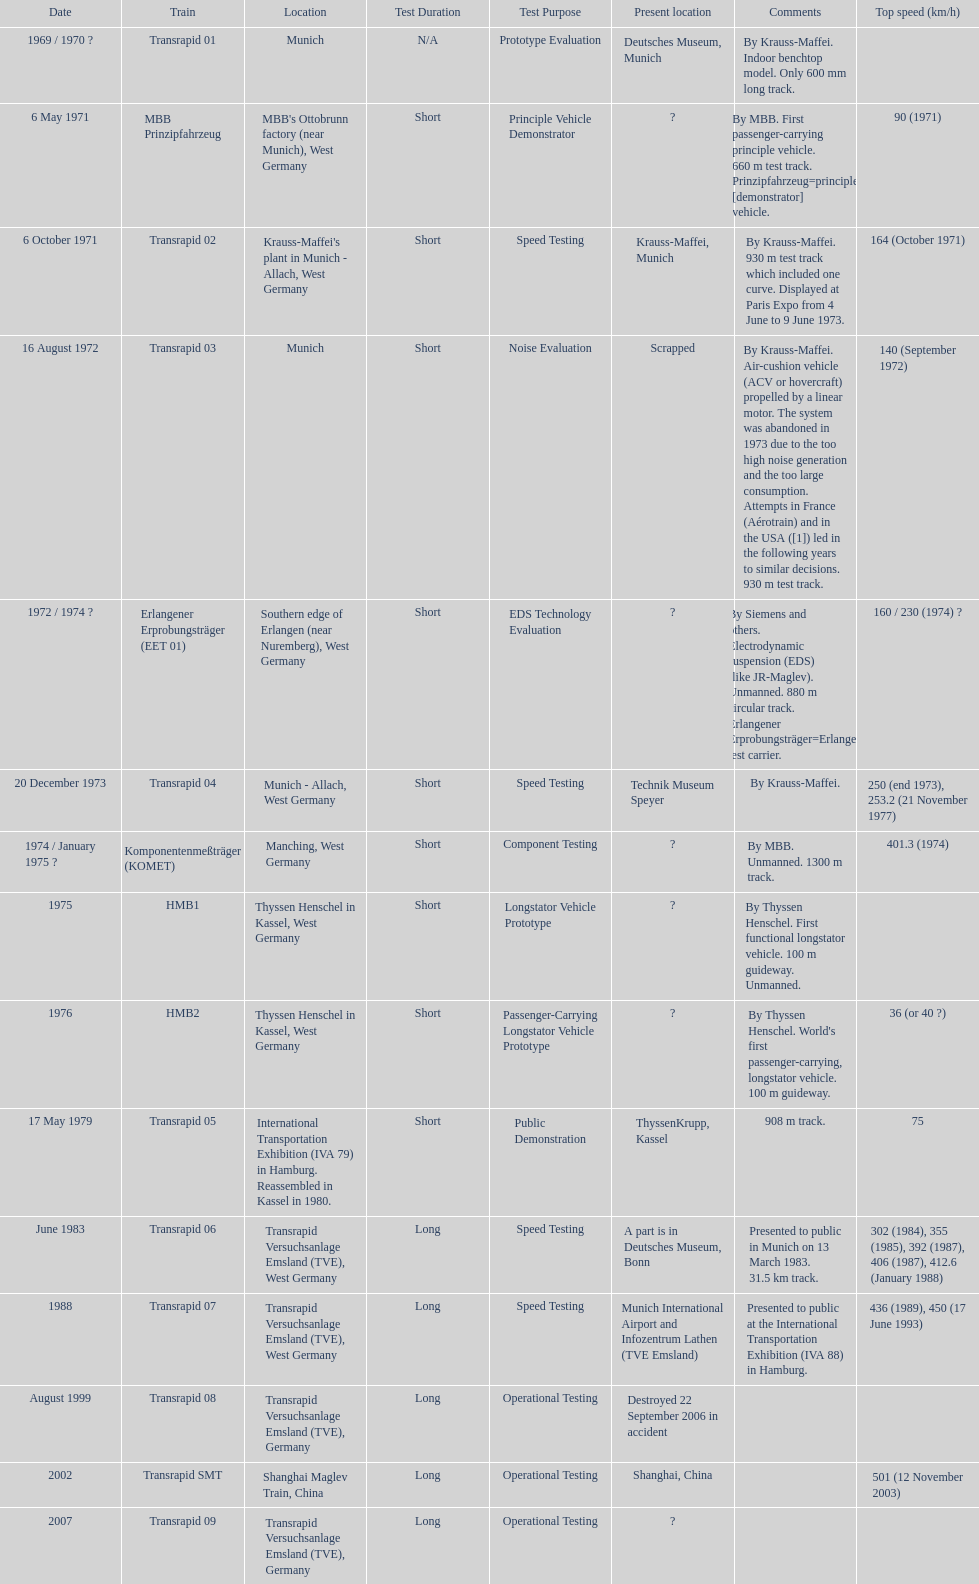What is the only train to reach a top speed of 500 or more? Transrapid SMT. 